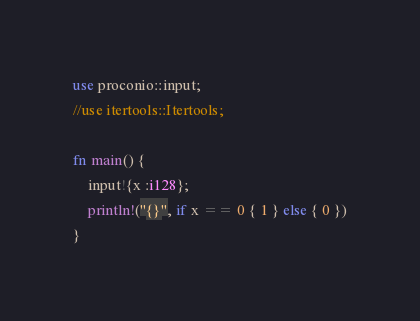<code> <loc_0><loc_0><loc_500><loc_500><_Rust_>use proconio::input;
//use itertools::Itertools;

fn main() {
    input!{x :i128};
    println!("{}", if x == 0 { 1 } else { 0 })
}</code> 